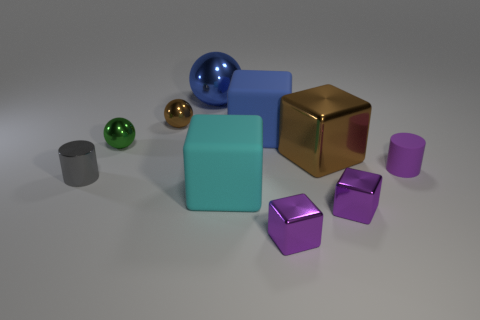Subtract all big metal cubes. How many cubes are left? 4 Subtract all cyan blocks. How many blocks are left? 4 Subtract 1 cubes. How many cubes are left? 4 Subtract all brown blocks. Subtract all cyan balls. How many blocks are left? 4 Subtract all cylinders. How many objects are left? 8 Add 6 blue matte cubes. How many blue matte cubes exist? 7 Subtract 1 blue cubes. How many objects are left? 9 Subtract all tiny brown objects. Subtract all purple blocks. How many objects are left? 7 Add 1 blue cubes. How many blue cubes are left? 2 